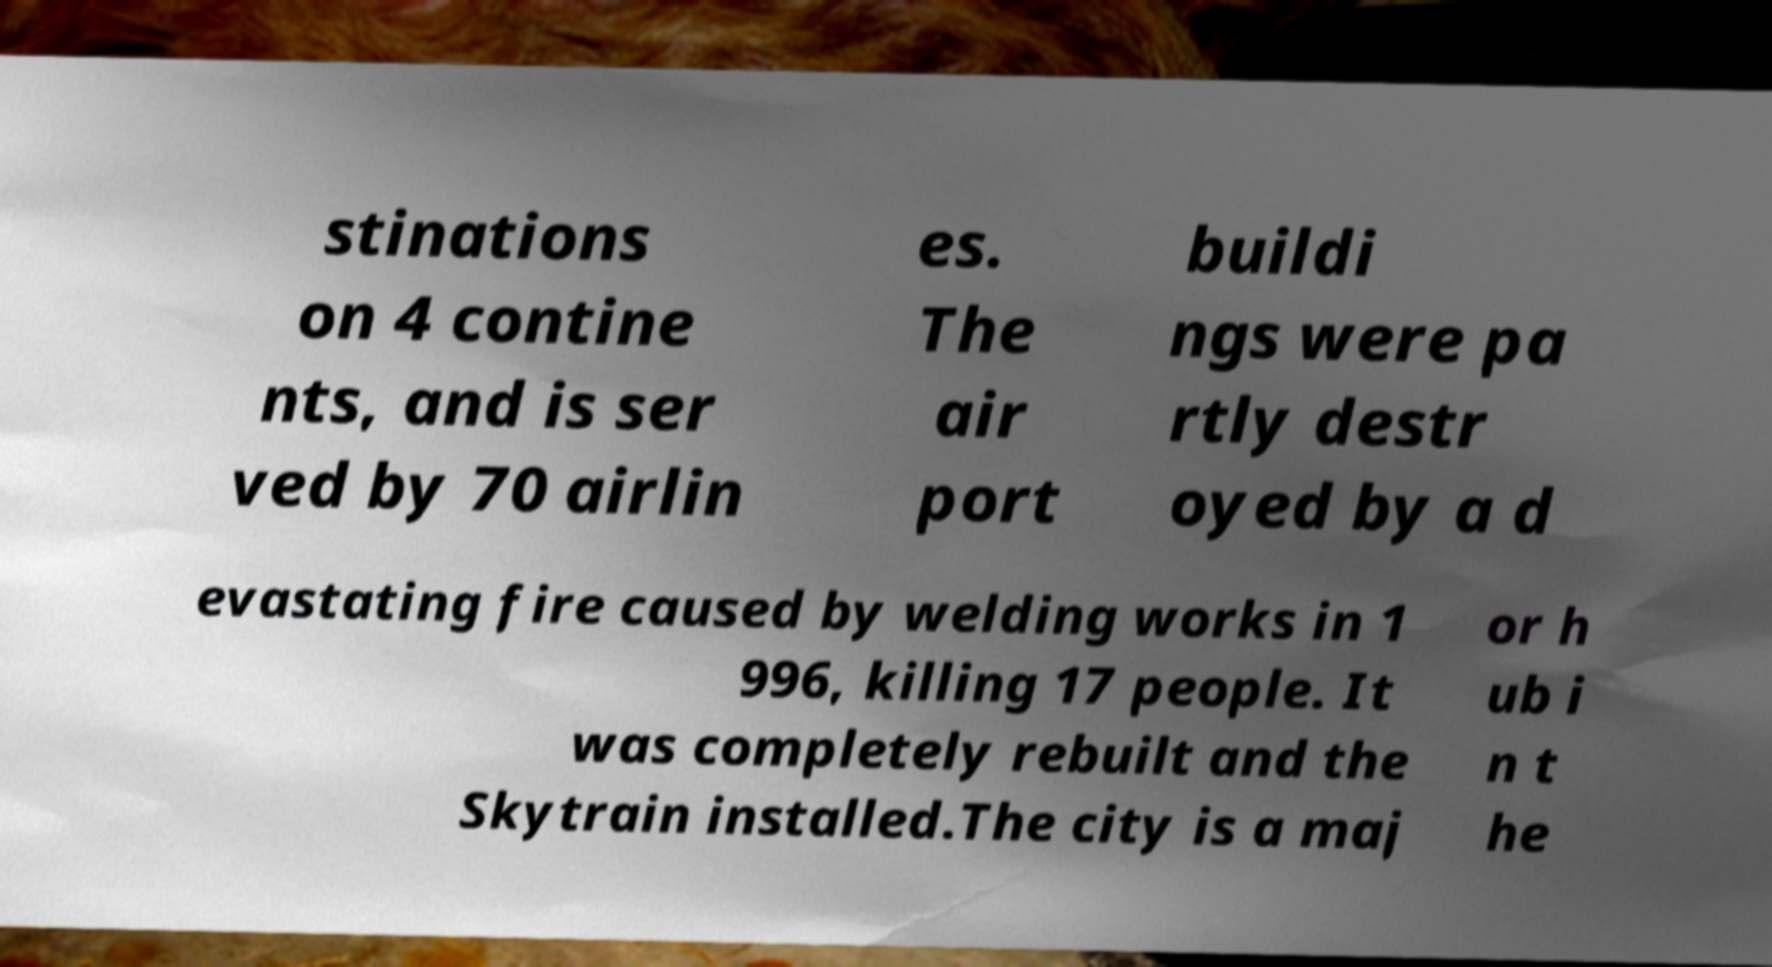There's text embedded in this image that I need extracted. Can you transcribe it verbatim? stinations on 4 contine nts, and is ser ved by 70 airlin es. The air port buildi ngs were pa rtly destr oyed by a d evastating fire caused by welding works in 1 996, killing 17 people. It was completely rebuilt and the Skytrain installed.The city is a maj or h ub i n t he 